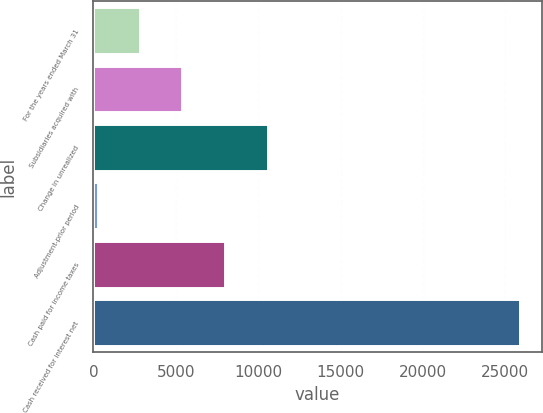<chart> <loc_0><loc_0><loc_500><loc_500><bar_chart><fcel>For the years ended March 31<fcel>Subsidiaries acquired with<fcel>Change in unrealized<fcel>Adjustment-prior period<fcel>Cash paid for income taxes<fcel>Cash received for interest net<nl><fcel>2825.2<fcel>5390.4<fcel>10576<fcel>260<fcel>7955.6<fcel>25912<nl></chart> 